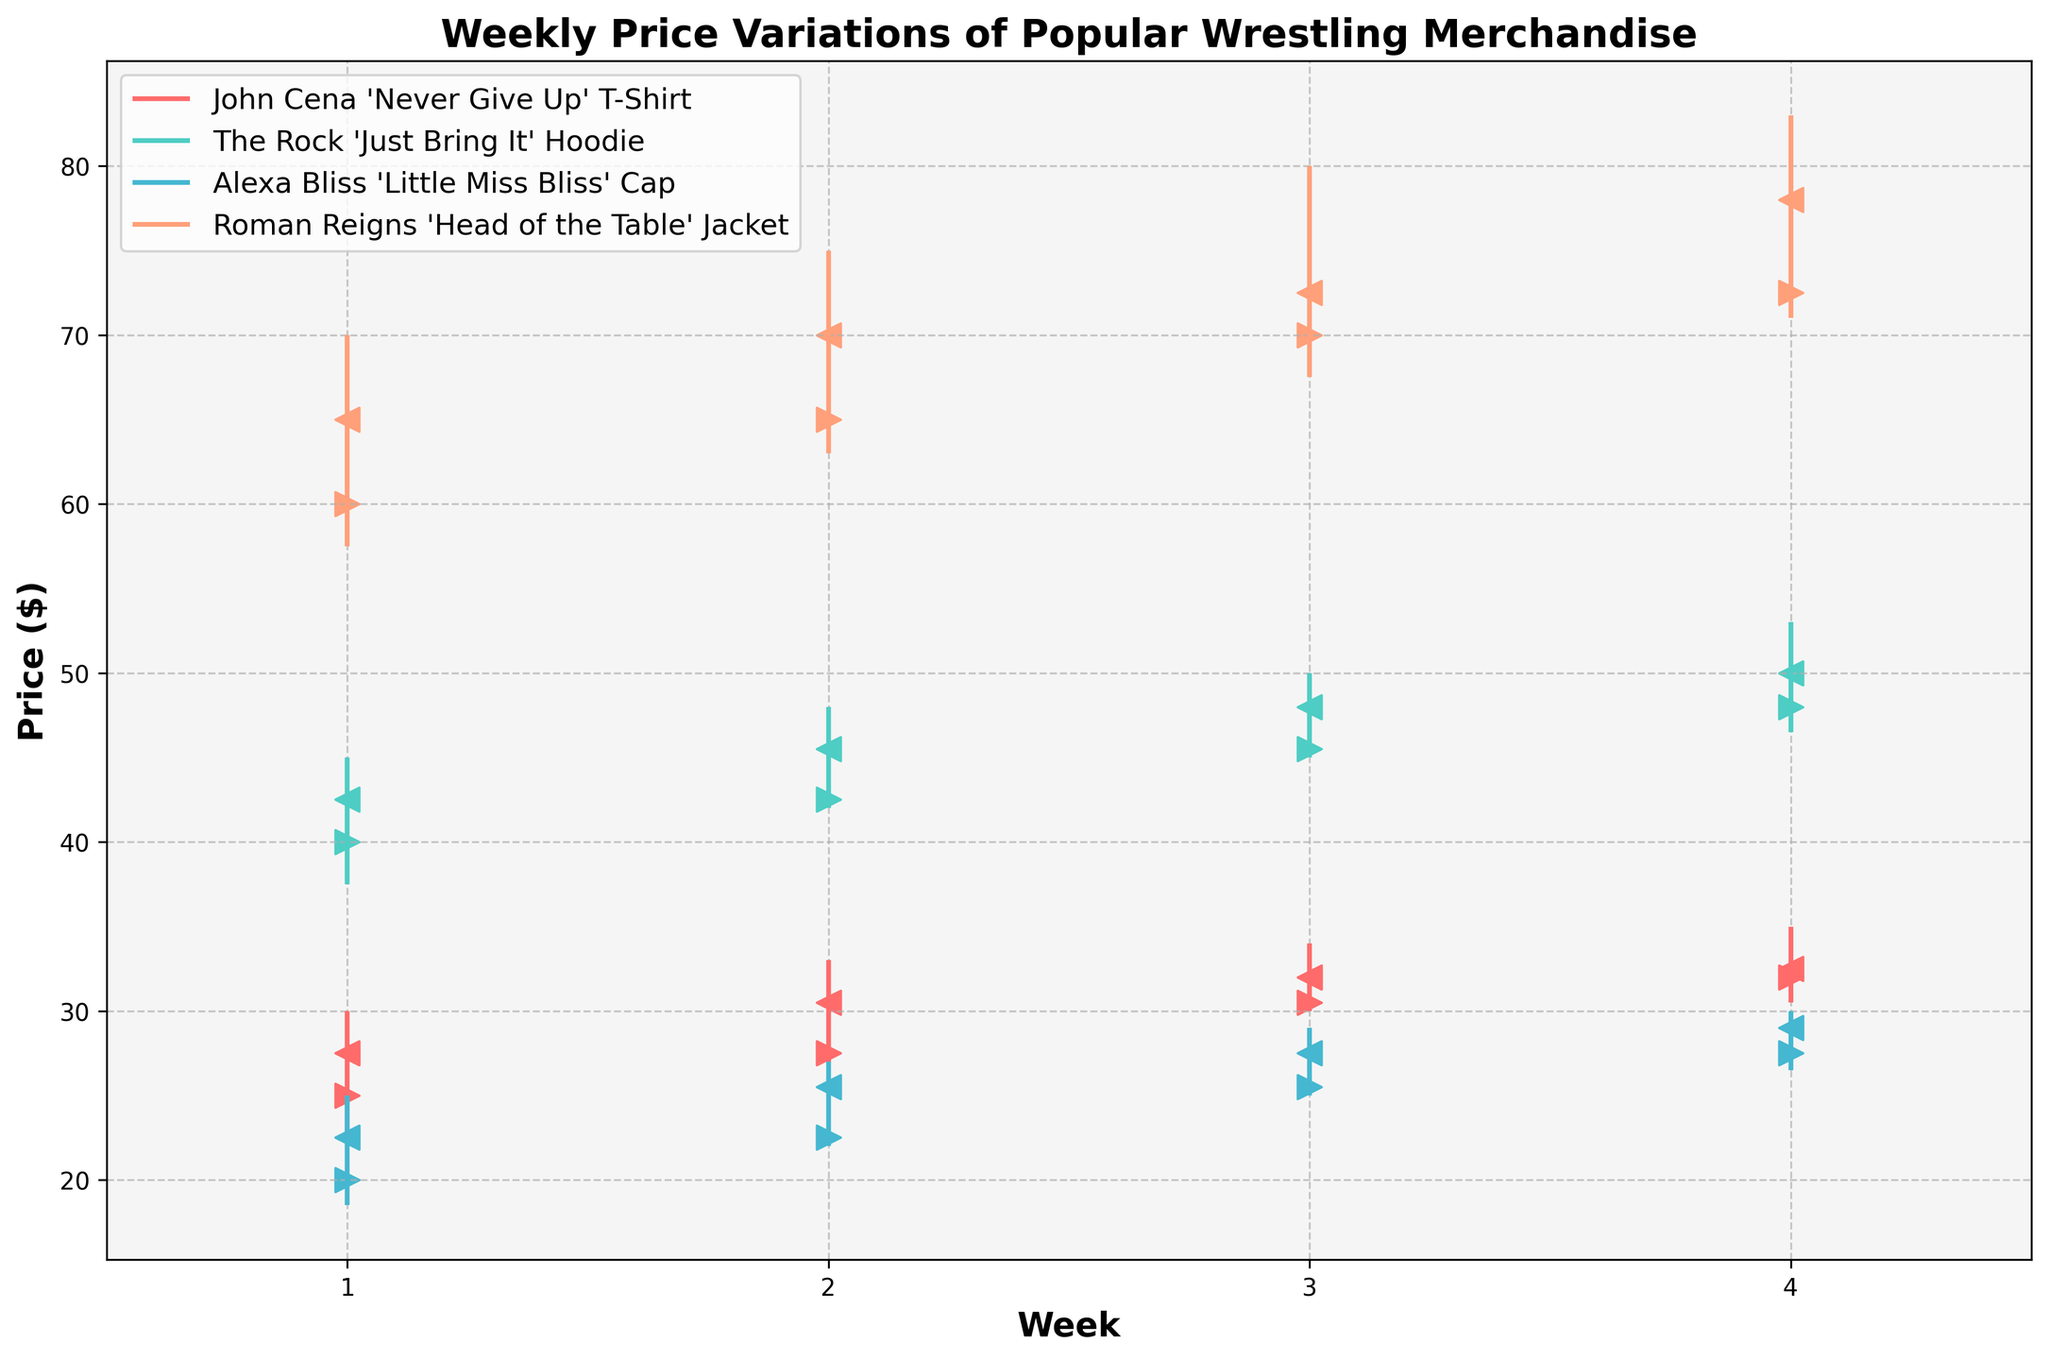What's the title of the chart? The chart's title is displayed at the top of the figure.
Answer: Weekly Price Variations of Popular Wrestling Merchandise What price range does the Y-axis cover? The Y-axis covers the range of prices from the lowest to the highest value seen across all wrestling merchandise, including all weeks. By observing, the lowest price starts slightly below $20, and the highest is just over $80.
Answer: $18.50 - $82.99 How many weeks of data are displayed in the chart? The X-axis shows the weekly intervals and the data points are plotted for a span of weeks. By counting the number of distinct weeks shown on the X-axis or from the data, we can see it spans 4 weeks.
Answer: 4 weeks Which item had the highest closing price across all weeks? By examining the closing prices for each item across all weeks, we identify that the 'Roman Reigns "Head of the Table" Jacket' had the highest closing price of $77.99 in Week 4.
Answer: Roman Reigns 'Head of the Table' Jacket Compare the opening prices of John Cena's T-Shirt and The Rock's Hoodie in the first week. Which item was cheaper? We compare the opening prices of two items during the first week. From the data, the opening price for 'John Cena "Never Give Up" T-Shirt' is $24.99, and for 'The Rock "Just Bring It" Hoodie' is $39.99. Hence, the T-shirt was cheaper.
Answer: John Cena 'Never Give Up' T-Shirt Calculate the average opening price of Alexa Bliss's Cap over the 4 weeks. To find the average opening price, sum all the opening prices for Alexa Bliss's Cap across the weeks and divide by the number of weeks: (19.99 + 22.50 + 25.50 + 27.50) / 4 = 23.37
Answer: $23.37 Which week did The Rock's Hoodie have its lowest price, and what was it? By looking at the low prices for each week for The Rock's Hoodie, it can be seen that the lowest price was $37.50 in the first week.
Answer: Week 1, $37.50 What was the price range for the Roman Reigns Jacket in the third week? The price range in any given week is the difference between the high and low prices. For Week 3, the high price of 'Roman Reigns "Head of the Table" Jacket' was $79.99 and the low was $67.50, making the range 79.99 - 67.50 = 12.49
Answer: $12.49 Which item showed the least variation in price in Week 4? The variance can be determined by subtracting the low price from the high price for each item in Week 4. Analyzing all items, Alexa Bliss's Cap had the narrowest range from $26.50 to $29.99, with a variation of 29.99 - 26.50 = 3.49.
Answer: Alexa Bliss 'Little Miss Bliss' Cap What's the highest recorded price across all items and weeks? By reviewing all the high values in the dataset for each item and week, it can be observed that the highest price recorded was for 'Roman Reigns "Head of the Table" Jacket' in Week 4 at $82.99.
Answer: $82.99 